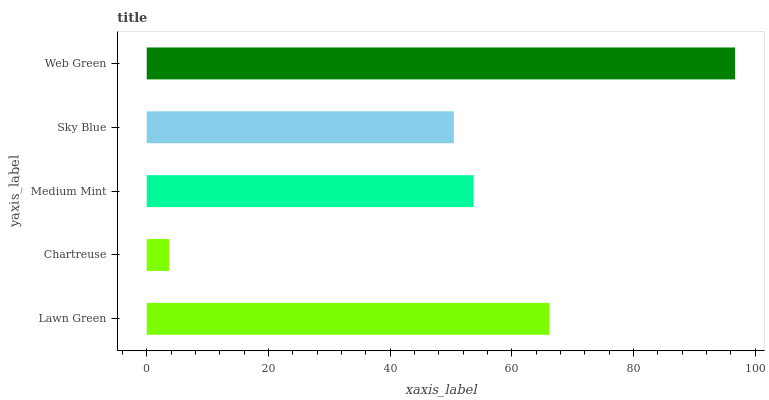Is Chartreuse the minimum?
Answer yes or no. Yes. Is Web Green the maximum?
Answer yes or no. Yes. Is Medium Mint the minimum?
Answer yes or no. No. Is Medium Mint the maximum?
Answer yes or no. No. Is Medium Mint greater than Chartreuse?
Answer yes or no. Yes. Is Chartreuse less than Medium Mint?
Answer yes or no. Yes. Is Chartreuse greater than Medium Mint?
Answer yes or no. No. Is Medium Mint less than Chartreuse?
Answer yes or no. No. Is Medium Mint the high median?
Answer yes or no. Yes. Is Medium Mint the low median?
Answer yes or no. Yes. Is Chartreuse the high median?
Answer yes or no. No. Is Chartreuse the low median?
Answer yes or no. No. 